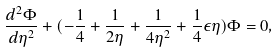<formula> <loc_0><loc_0><loc_500><loc_500>\frac { d ^ { 2 } \Phi } { d \eta ^ { 2 } } + ( - \frac { 1 } { 4 } + \frac { 1 } { 2 \eta } + \frac { 1 } { 4 \eta ^ { 2 } } + \frac { 1 } { 4 } \epsilon \eta ) \Phi = 0 ,</formula> 